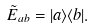Convert formula to latex. <formula><loc_0><loc_0><loc_500><loc_500>\tilde { E } _ { a b } = | a \rangle \langle b | .</formula> 